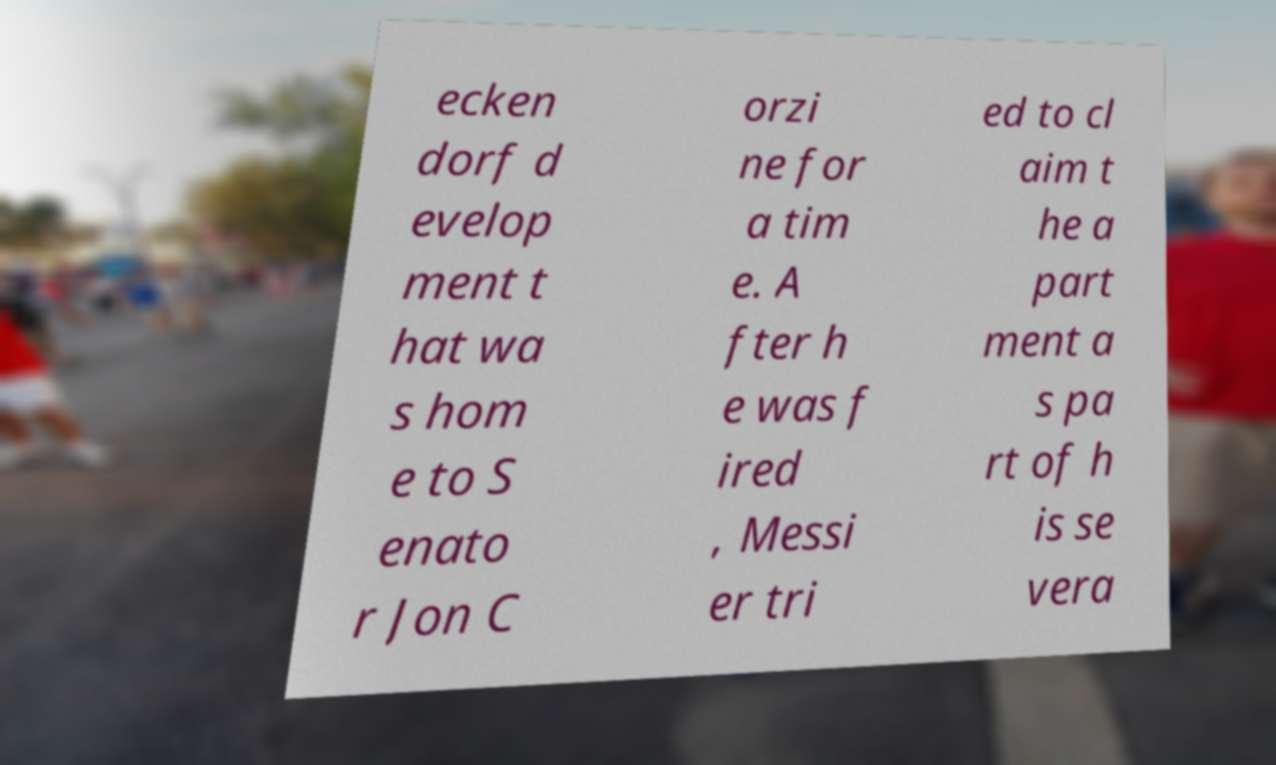There's text embedded in this image that I need extracted. Can you transcribe it verbatim? ecken dorf d evelop ment t hat wa s hom e to S enato r Jon C orzi ne for a tim e. A fter h e was f ired , Messi er tri ed to cl aim t he a part ment a s pa rt of h is se vera 